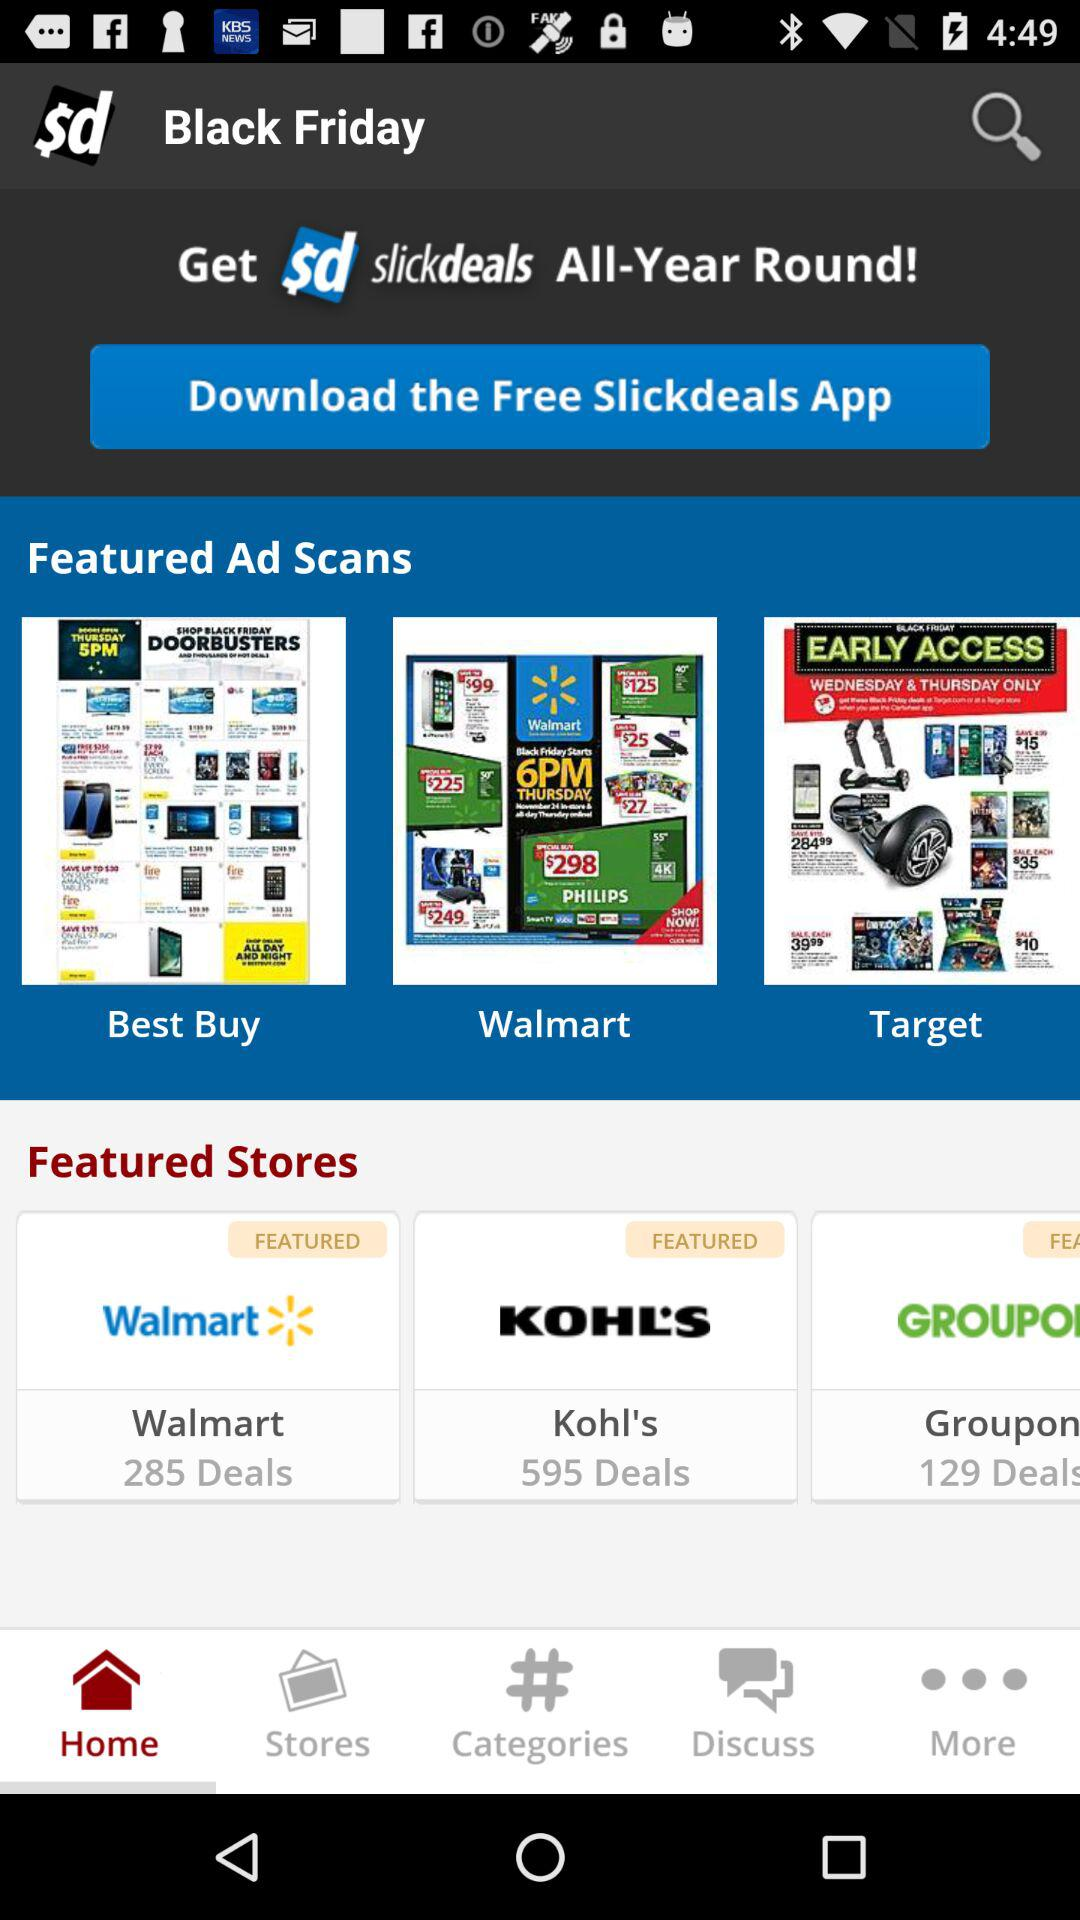What is the number of deals at "Walmart"? The number of deals is 285. 